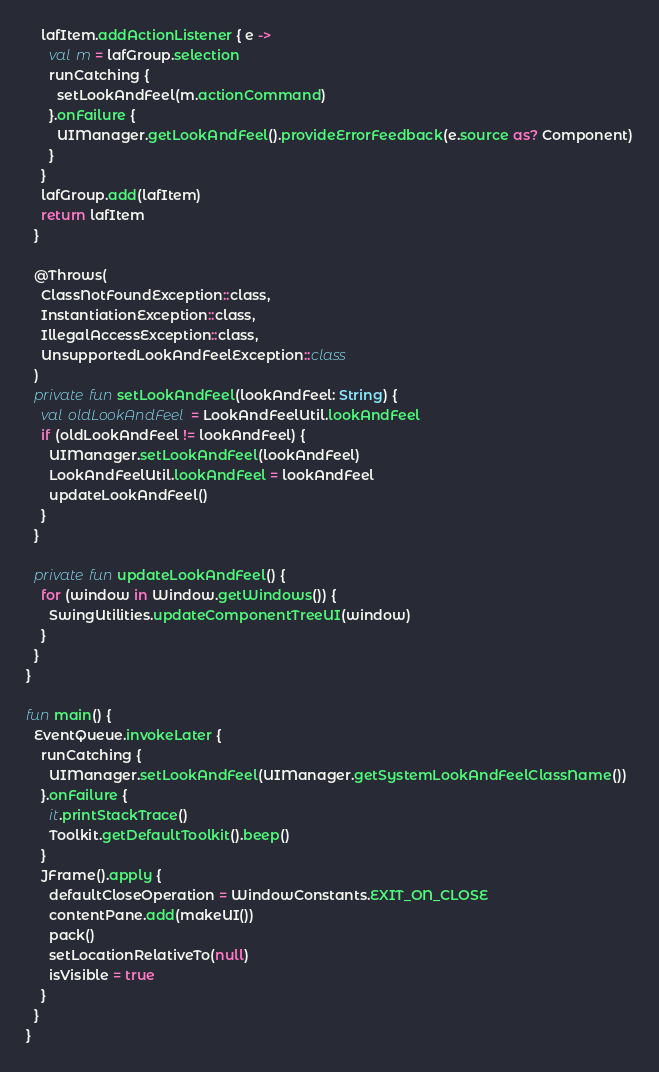Convert code to text. <code><loc_0><loc_0><loc_500><loc_500><_Kotlin_>    lafItem.addActionListener { e ->
      val m = lafGroup.selection
      runCatching {
        setLookAndFeel(m.actionCommand)
      }.onFailure {
        UIManager.getLookAndFeel().provideErrorFeedback(e.source as? Component)
      }
    }
    lafGroup.add(lafItem)
    return lafItem
  }

  @Throws(
    ClassNotFoundException::class,
    InstantiationException::class,
    IllegalAccessException::class,
    UnsupportedLookAndFeelException::class
  )
  private fun setLookAndFeel(lookAndFeel: String) {
    val oldLookAndFeel = LookAndFeelUtil.lookAndFeel
    if (oldLookAndFeel != lookAndFeel) {
      UIManager.setLookAndFeel(lookAndFeel)
      LookAndFeelUtil.lookAndFeel = lookAndFeel
      updateLookAndFeel()
    }
  }

  private fun updateLookAndFeel() {
    for (window in Window.getWindows()) {
      SwingUtilities.updateComponentTreeUI(window)
    }
  }
}

fun main() {
  EventQueue.invokeLater {
    runCatching {
      UIManager.setLookAndFeel(UIManager.getSystemLookAndFeelClassName())
    }.onFailure {
      it.printStackTrace()
      Toolkit.getDefaultToolkit().beep()
    }
    JFrame().apply {
      defaultCloseOperation = WindowConstants.EXIT_ON_CLOSE
      contentPane.add(makeUI())
      pack()
      setLocationRelativeTo(null)
      isVisible = true
    }
  }
}
</code> 